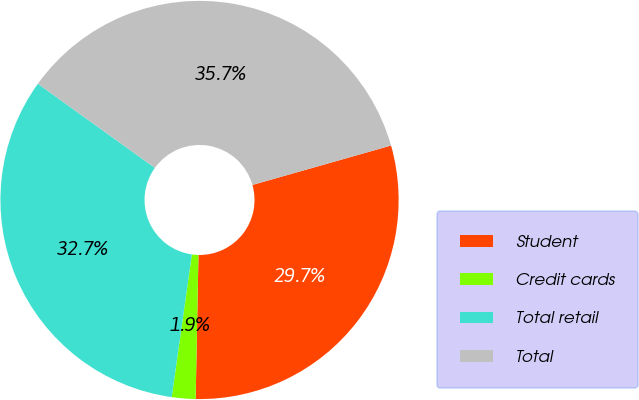Convert chart to OTSL. <chart><loc_0><loc_0><loc_500><loc_500><pie_chart><fcel>Student<fcel>Credit cards<fcel>Total retail<fcel>Total<nl><fcel>29.72%<fcel>1.92%<fcel>32.69%<fcel>35.67%<nl></chart> 